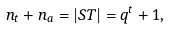<formula> <loc_0><loc_0><loc_500><loc_500>n _ { t } + n _ { a } = | S T | = q ^ { t } + 1 ,</formula> 